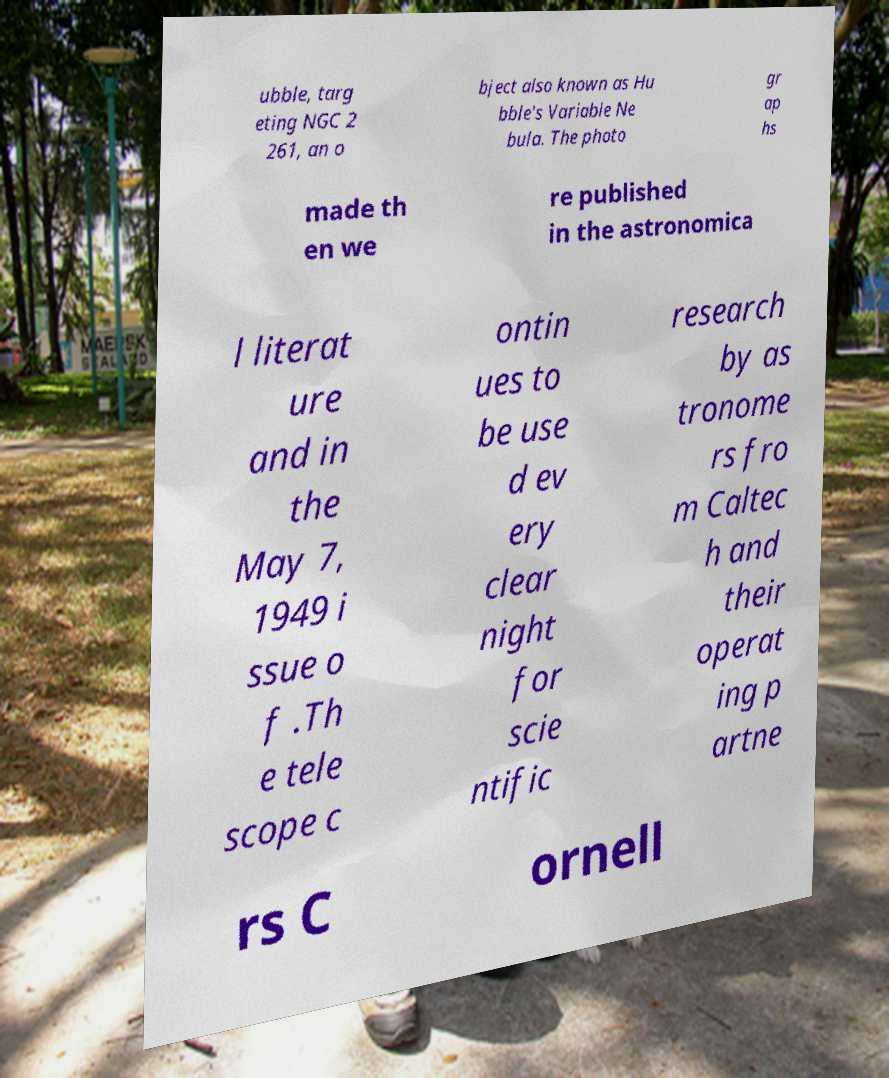For documentation purposes, I need the text within this image transcribed. Could you provide that? ubble, targ eting NGC 2 261, an o bject also known as Hu bble's Variable Ne bula. The photo gr ap hs made th en we re published in the astronomica l literat ure and in the May 7, 1949 i ssue o f .Th e tele scope c ontin ues to be use d ev ery clear night for scie ntific research by as tronome rs fro m Caltec h and their operat ing p artne rs C ornell 